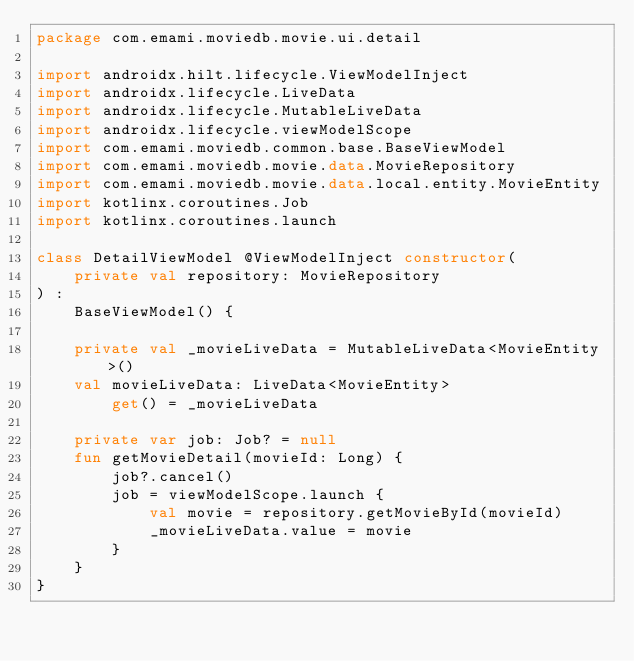<code> <loc_0><loc_0><loc_500><loc_500><_Kotlin_>package com.emami.moviedb.movie.ui.detail

import androidx.hilt.lifecycle.ViewModelInject
import androidx.lifecycle.LiveData
import androidx.lifecycle.MutableLiveData
import androidx.lifecycle.viewModelScope
import com.emami.moviedb.common.base.BaseViewModel
import com.emami.moviedb.movie.data.MovieRepository
import com.emami.moviedb.movie.data.local.entity.MovieEntity
import kotlinx.coroutines.Job
import kotlinx.coroutines.launch

class DetailViewModel @ViewModelInject constructor(
    private val repository: MovieRepository
) :
    BaseViewModel() {

    private val _movieLiveData = MutableLiveData<MovieEntity>()
    val movieLiveData: LiveData<MovieEntity>
        get() = _movieLiveData

    private var job: Job? = null
    fun getMovieDetail(movieId: Long) {
        job?.cancel()
        job = viewModelScope.launch {
            val movie = repository.getMovieById(movieId)
            _movieLiveData.value = movie
        }
    }
}</code> 